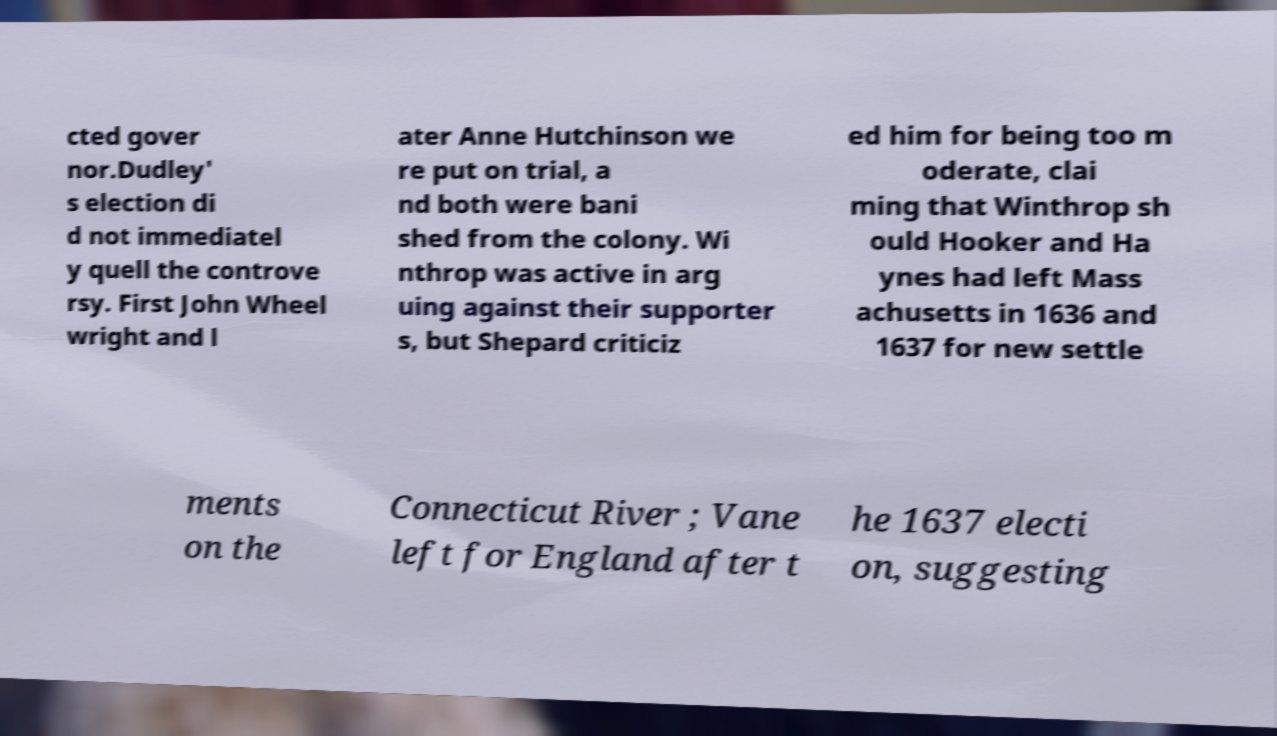Please identify and transcribe the text found in this image. cted gover nor.Dudley' s election di d not immediatel y quell the controve rsy. First John Wheel wright and l ater Anne Hutchinson we re put on trial, a nd both were bani shed from the colony. Wi nthrop was active in arg uing against their supporter s, but Shepard criticiz ed him for being too m oderate, clai ming that Winthrop sh ould Hooker and Ha ynes had left Mass achusetts in 1636 and 1637 for new settle ments on the Connecticut River ; Vane left for England after t he 1637 electi on, suggesting 